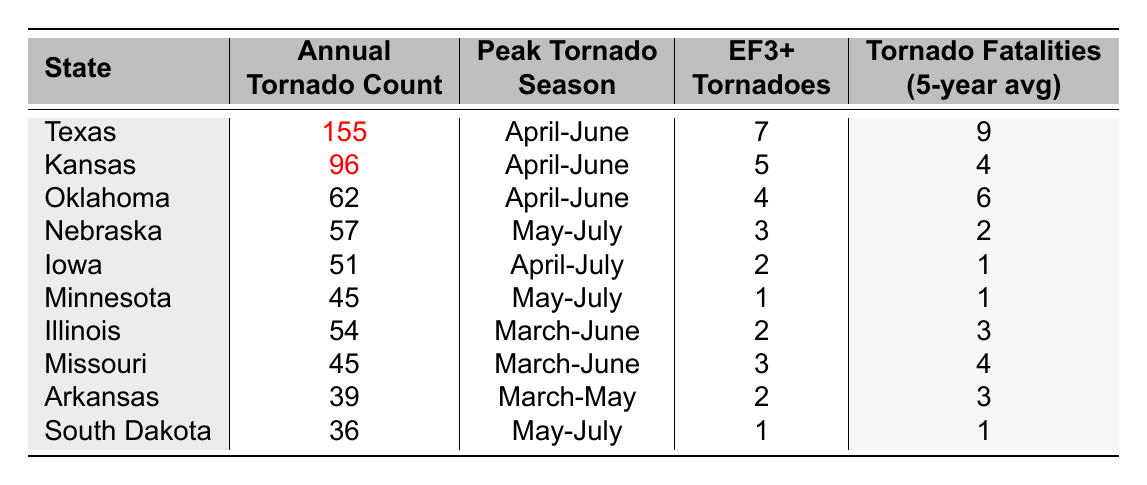What state has the highest annual tornado count? The table shows that Texas has the highest annual tornado count at 155 tornadoes.
Answer: Texas How many EF3+ tornadoes occur on average in Oklahoma? Oklahoma has 4 EF3+ tornadoes, which is explicitly stated in the table.
Answer: 4 Is the peak tornado season the same for all states listed? Upon reviewing the table, I can see that not all states have the same peak tornado season. Some states like Texas, Kansas, Oklahoma have April-June, while others have different ranges such as May-July.
Answer: No Which state recorded the lowest average number of tornado fatalities over the past five years? Looking at the column for tornado fatalities, South Dakota has the lowest average at 1.
Answer: South Dakota What is the total annual tornado count for Kansas, Oklahoma, and Nebraska combined? To find the total, add the annual counts: Kansas (96) + Oklahoma (62) + Nebraska (57) = 215.
Answer: 215 How many states have an annual tornado count greater than 50? The states with counts greater than 50 are Texas, Kansas, Oklahoma, Nebraska, Iowa, and Illinois. That totals 6 states.
Answer: 6 Which state experiences the peak tornado season from May to July? Nebraska and Minnesota have their peak tornado season from May to July according to the table.
Answer: Nebraska and Minnesota What is the average number of EF3+ tornadoes for the states listed? Add the EF3+ counts and divide by the number of states: (7 + 5 + 4 + 3 + 2 + 1 + 2 + 3 + 2 + 1) = 30; then divide by 10, giving an average of 3.
Answer: 3 Which state has more tornado fatalities than Arkansas over the five-year average? By examining the tornado fatalities, Oklahoma (6) and Missouri (4) have more fatalities than Arkansas (3).
Answer: Oklahoma and Missouri Is there a state that has both the lowest annual tornado count and the lowest EF3+ tornadoes? Yes, South Dakota has both the lowest annual tornado count (36) and lowest EF3+ tornadoes (1).
Answer: Yes 